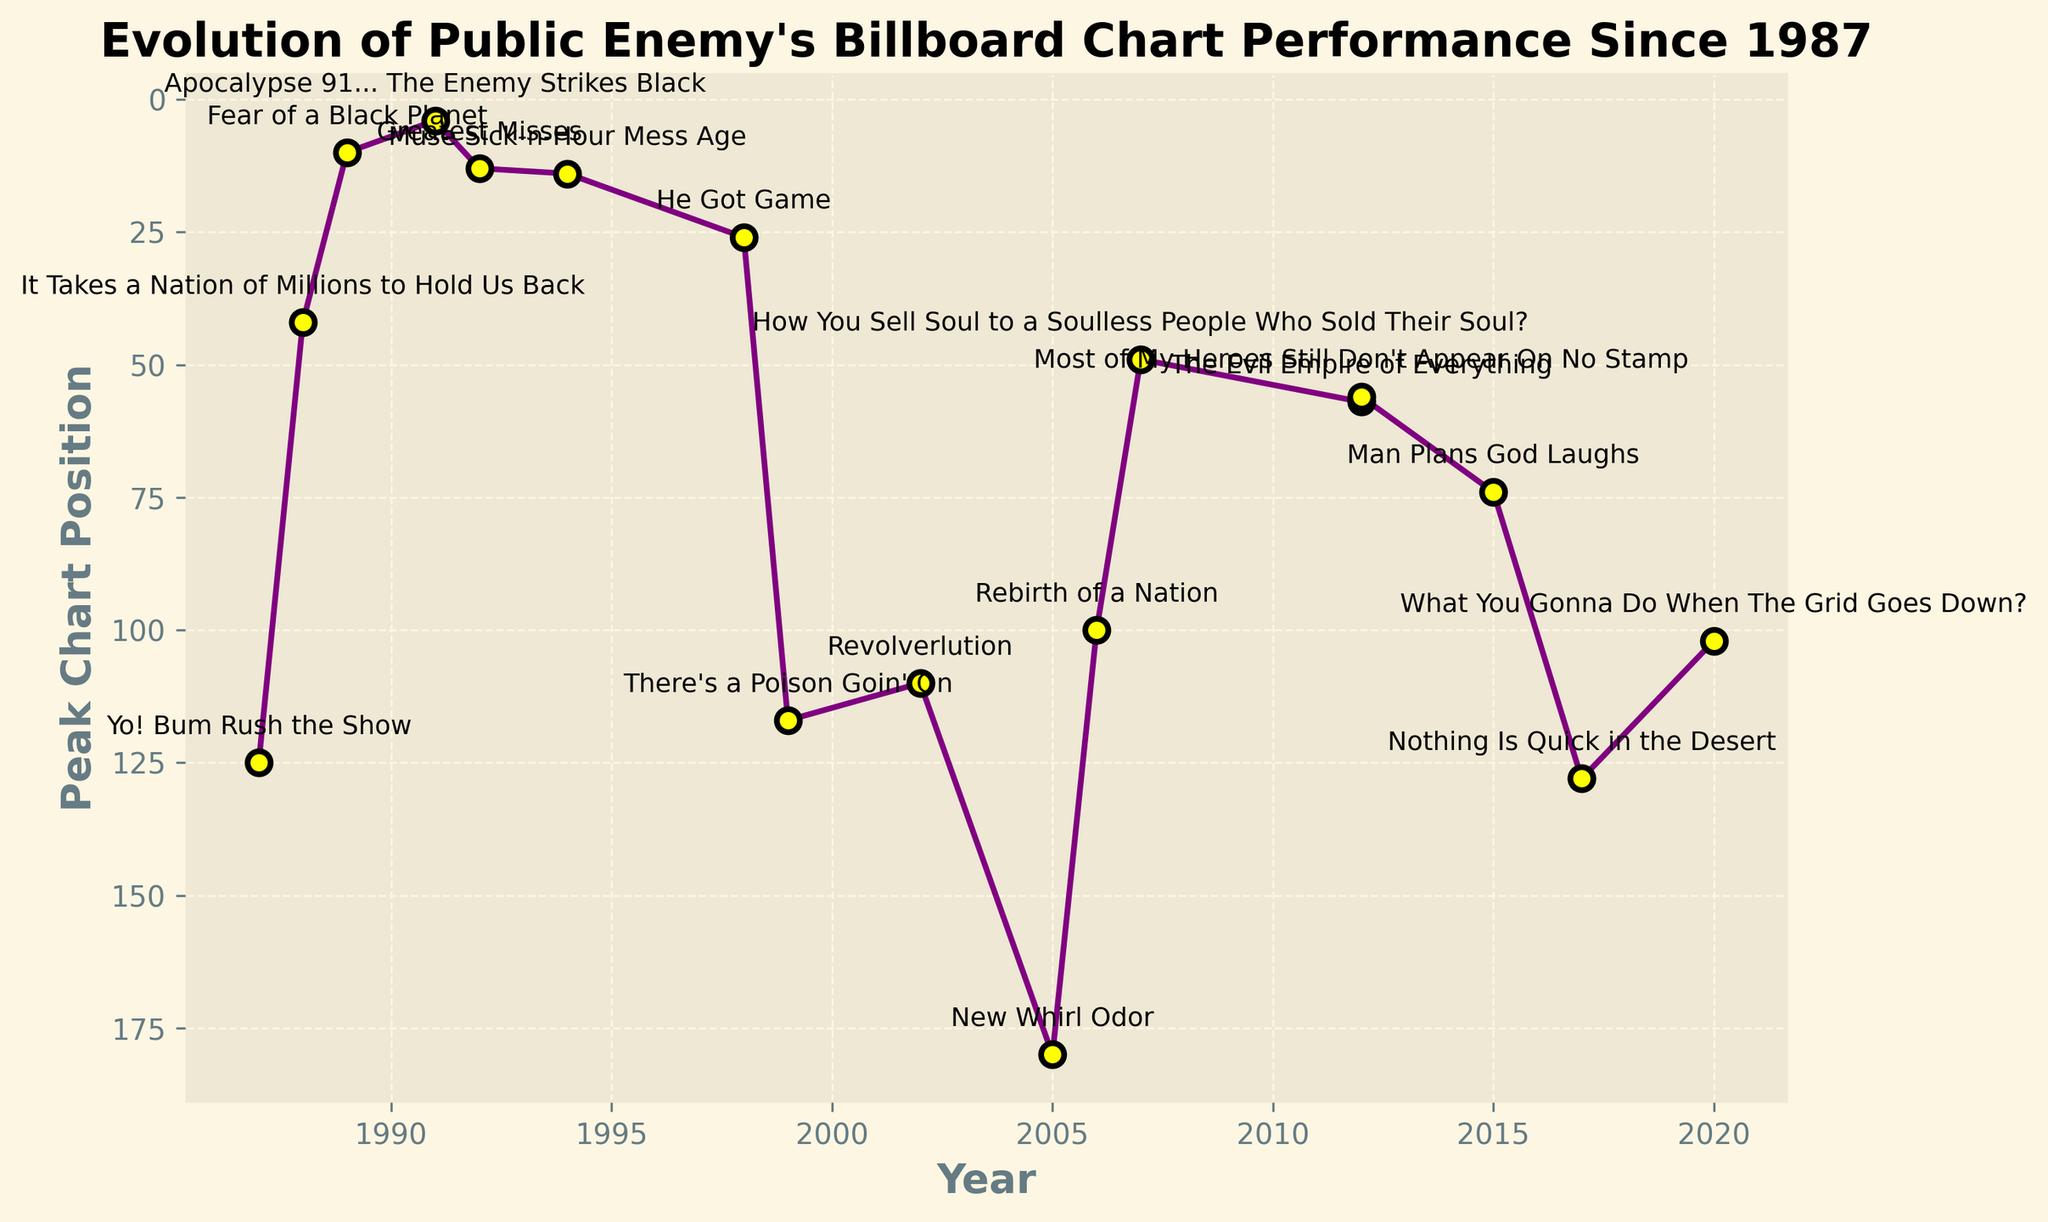What's the peak chart position of "Fear of a Black Planet"? To find this, look at where "Fear of a Black Planet" is labeled on the figure and note its corresponding peak chart position.
Answer: 10 Which album reached Public Enemy's highest ever peak chart position on the Billboard chart? To determine this, observe which data point is closest to the top of the inverted y-axis (position 1 is the highest). Identify the corresponding album.
Answer: Apocalypse 91... The Enemy Strikes Black Comparing "Yo! Bum Rush the Show" and "Muse Sick-n-Hour Mess Age," which album performed better on the Billboard chart? Locate the data points for both albums and compare their positions. Since the y-axis is inverted, the album with the lower numerical value performed better.
Answer: Muse Sick-n-Hour Mess Age What is the trend in Public Enemy’s chart performance between 1987 and 1991? Look at the trajectory of the line connecting the data points from 1987 to 1991. Identify if it goes upwards or downwards.
Answer: There is an upward trend (i.e., improving chart positions) What is the median peak chart position of Public Enemy's albums released between 1994 and 2017? Identify the peak positions for the albums in the given range (1994, 1998, 1999, 2002, 2005, 2006, 2007, 2012, 2012, 2015, 2017), arrange them in numerical order, and find the middle value. The positions are [14, 26, 49, 56, 57, 74, 100, 102, 110, 117, 128, 180]. The middle values are 74 and 100, so the median is (74+100)/2.
Answer: 87 Which period saw the steepest decline in chart performance? Analyze the slope of the line segments between successive data points and identify where the drop is the steepest.
Answer: Between 1992 (Greatest Misses) and 2005 (New Whirl Odor) By how many positions did the chart peak improve between "New Whirl Odor" and "What You Gonna Do When The Grid Goes Down?" Identify the peak positions for both albums (180 for "New Whirl Odor" in 2005 and 102 for "What You Gonna Do When The Grid Goes Down?" in 2020). Calculate the difference.
Answer: 78 How many albums reached a peak chart position better than 50? Count the number of albums where the corresponding data point is above the y = 50 mark in the inverted y-axis plot. These are [It Takes a Nation of Millions to Hold Us Back, Fear of a Black Planet, Apocalypse 91... The Enemy Strikes Black, Greatest Misses, Muse Sick-n-Hour Mess Age, How You Sell Soul to a Soulless People Who Sold Their Soul?, Most of My Heroes Still Don't Appear On No Stamp].
Answer: 7 